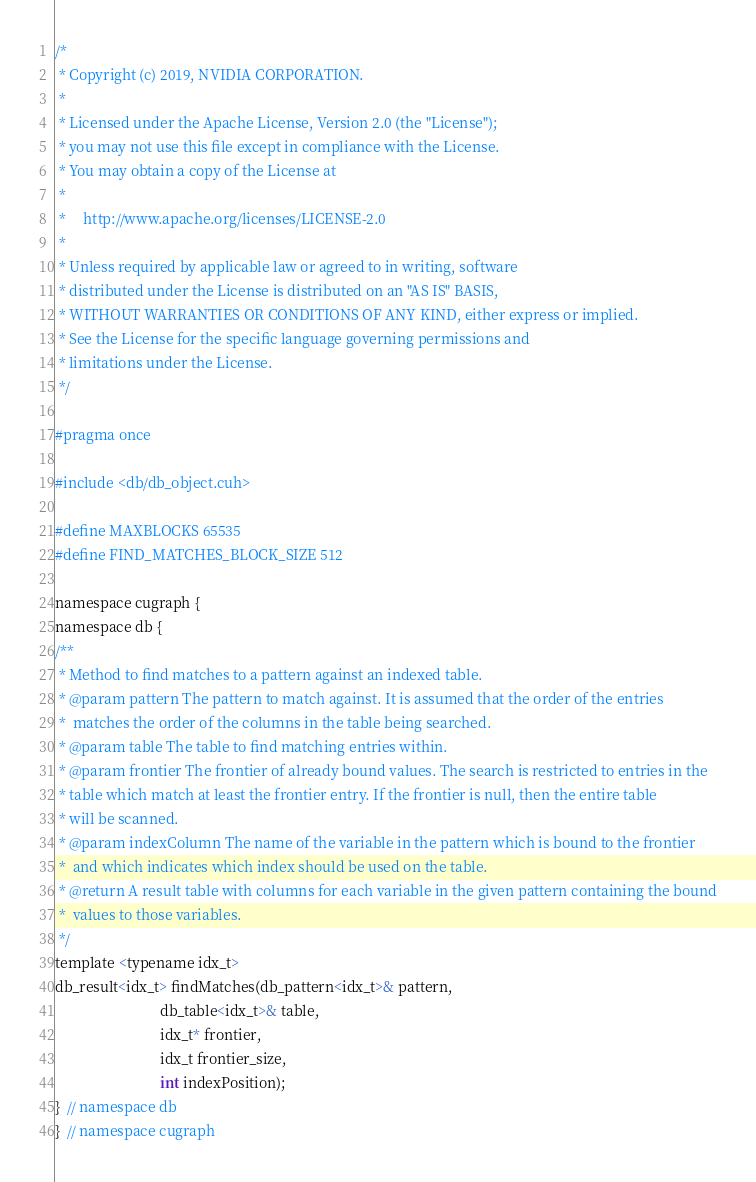<code> <loc_0><loc_0><loc_500><loc_500><_Cuda_>/*
 * Copyright (c) 2019, NVIDIA CORPORATION.
 *
 * Licensed under the Apache License, Version 2.0 (the "License");
 * you may not use this file except in compliance with the License.
 * You may obtain a copy of the License at
 *
 *     http://www.apache.org/licenses/LICENSE-2.0
 *
 * Unless required by applicable law or agreed to in writing, software
 * distributed under the License is distributed on an "AS IS" BASIS,
 * WITHOUT WARRANTIES OR CONDITIONS OF ANY KIND, either express or implied.
 * See the License for the specific language governing permissions and
 * limitations under the License.
 */

#pragma once

#include <db/db_object.cuh>

#define MAXBLOCKS 65535
#define FIND_MATCHES_BLOCK_SIZE 512

namespace cugraph {
namespace db {
/**
 * Method to find matches to a pattern against an indexed table.
 * @param pattern The pattern to match against. It is assumed that the order of the entries
 *  matches the order of the columns in the table being searched.
 * @param table The table to find matching entries within.
 * @param frontier The frontier of already bound values. The search is restricted to entries in the
 * table which match at least the frontier entry. If the frontier is null, then the entire table
 * will be scanned.
 * @param indexColumn The name of the variable in the pattern which is bound to the frontier
 *  and which indicates which index should be used on the table.
 * @return A result table with columns for each variable in the given pattern containing the bound
 *  values to those variables.
 */
template <typename idx_t>
db_result<idx_t> findMatches(db_pattern<idx_t>& pattern,
                             db_table<idx_t>& table,
                             idx_t* frontier,
                             idx_t frontier_size,
                             int indexPosition);
}  // namespace db
}  // namespace cugraph
</code> 